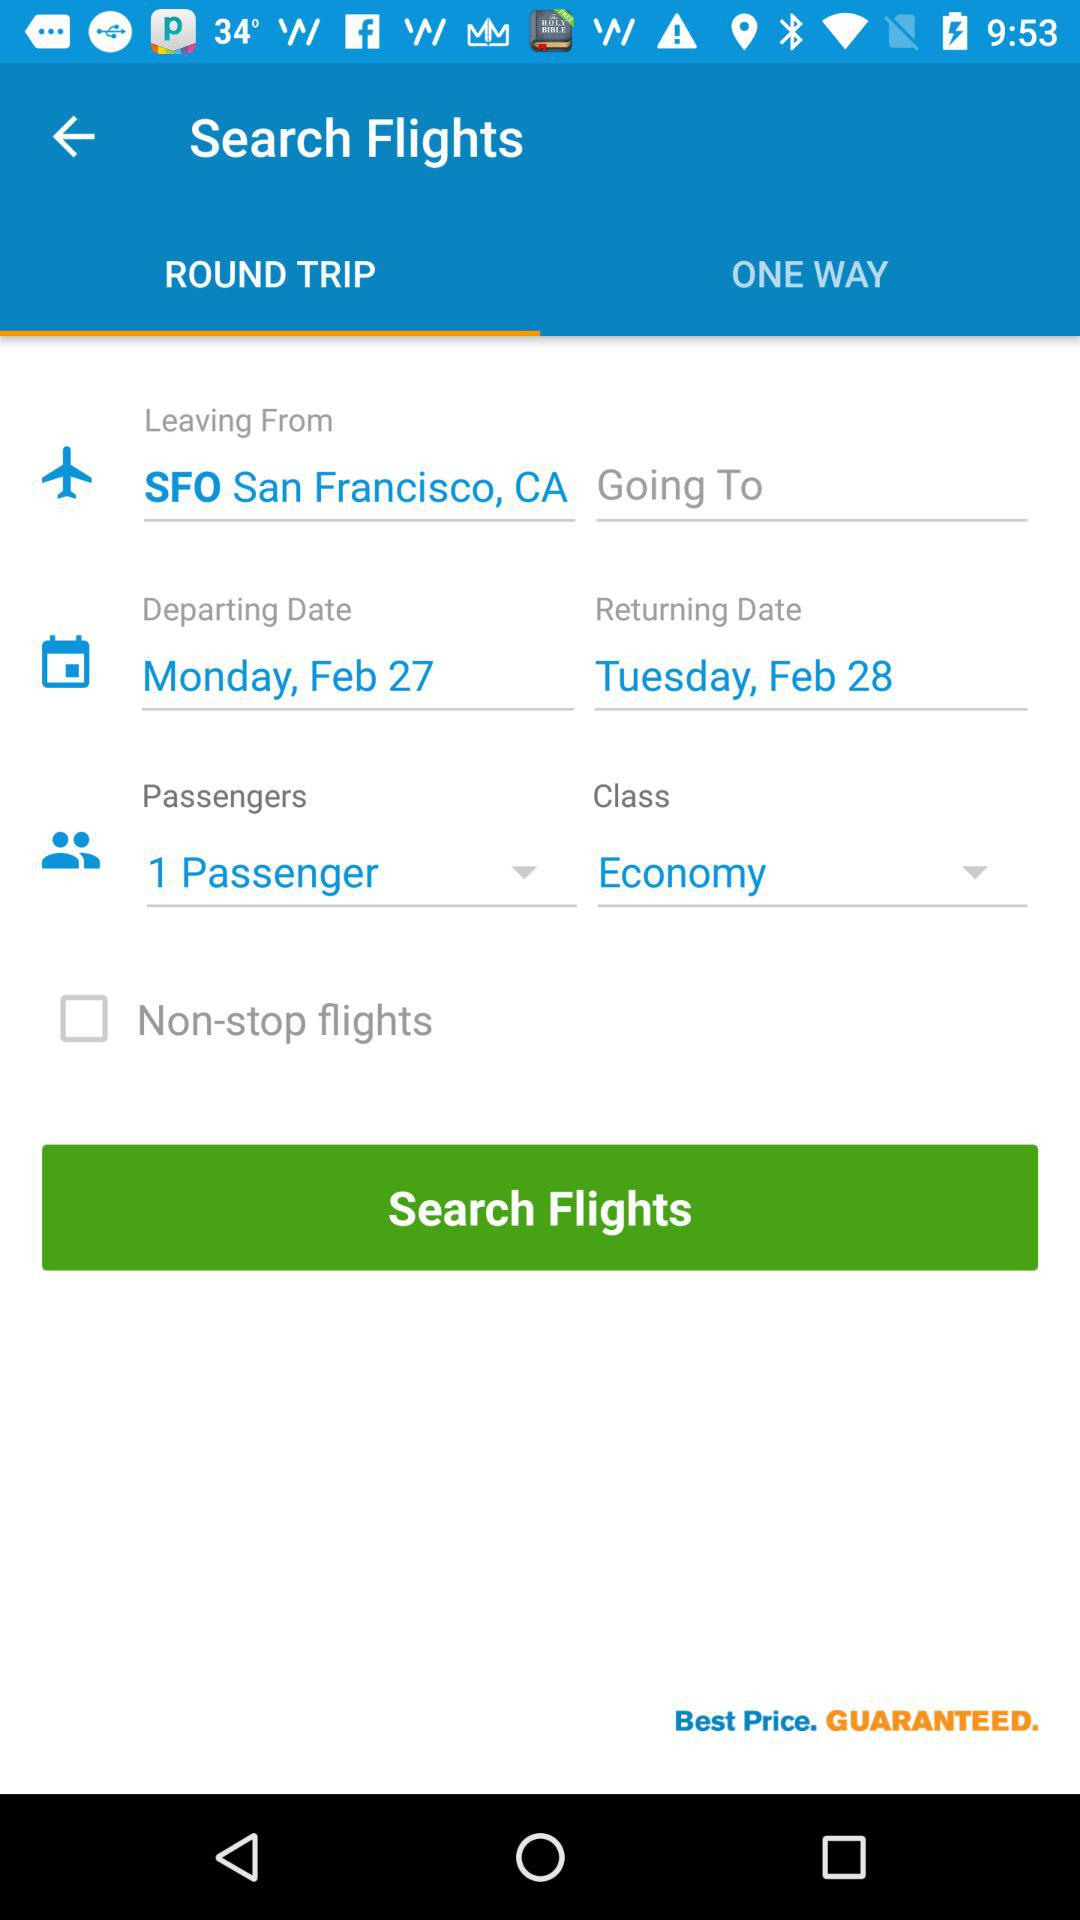Which tab is selected? The selected tab is "ROUND TRIP". 